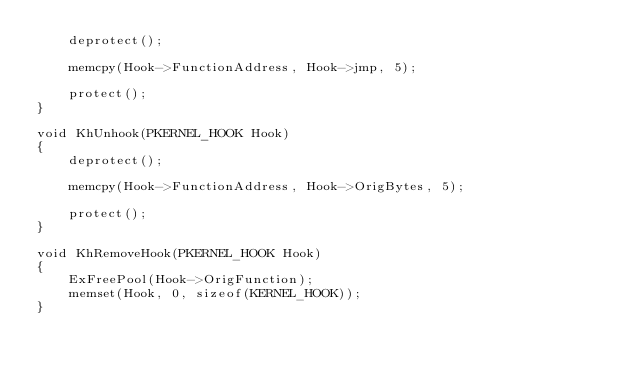<code> <loc_0><loc_0><loc_500><loc_500><_C_>	deprotect();

	memcpy(Hook->FunctionAddress, Hook->jmp, 5);

	protect();
}

void KhUnhook(PKERNEL_HOOK Hook)
{
	deprotect();

	memcpy(Hook->FunctionAddress, Hook->OrigBytes, 5);

	protect();
}

void KhRemoveHook(PKERNEL_HOOK Hook)
{
	ExFreePool(Hook->OrigFunction);
	memset(Hook, 0, sizeof(KERNEL_HOOK));
}</code> 